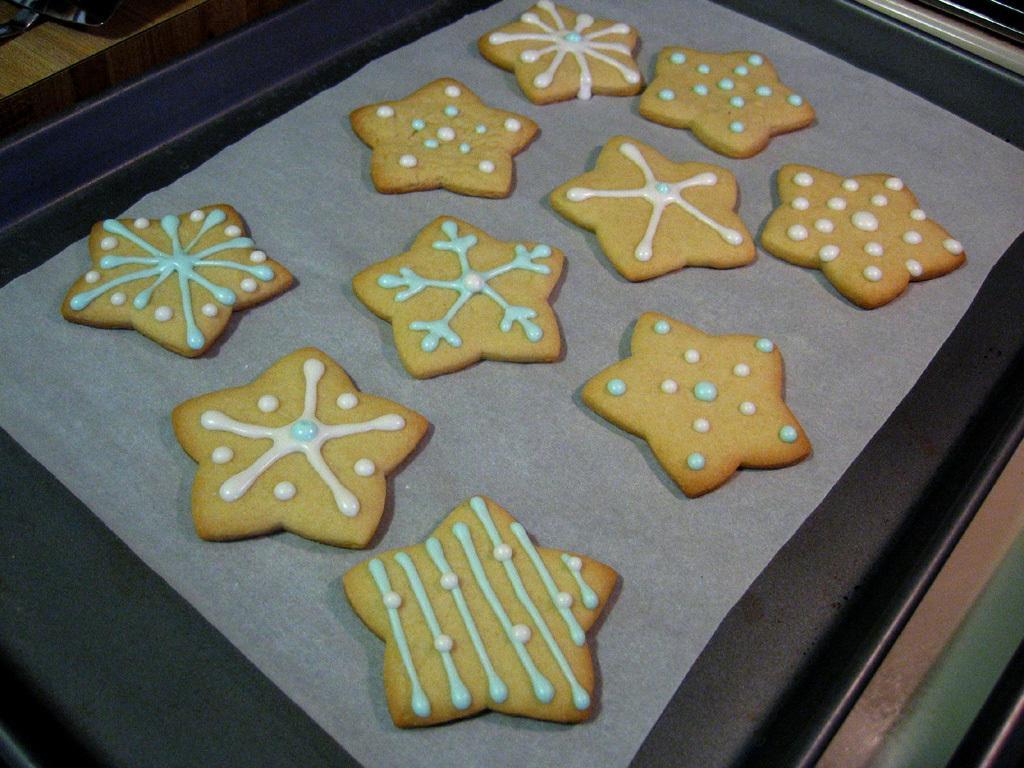How would you summarize this image in a sentence or two? In this image, we can see cookies with cream is placed on the paper. This paper is there on the black tray. 